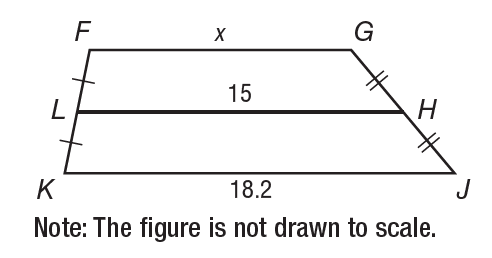Answer the mathemtical geometry problem and directly provide the correct option letter.
Question: In the figure, L H is the midsegment of trapezoid F G J K. What is the value of x?
Choices: A: 11.8 B: 15 C: 18.2 D: 33.2 A 